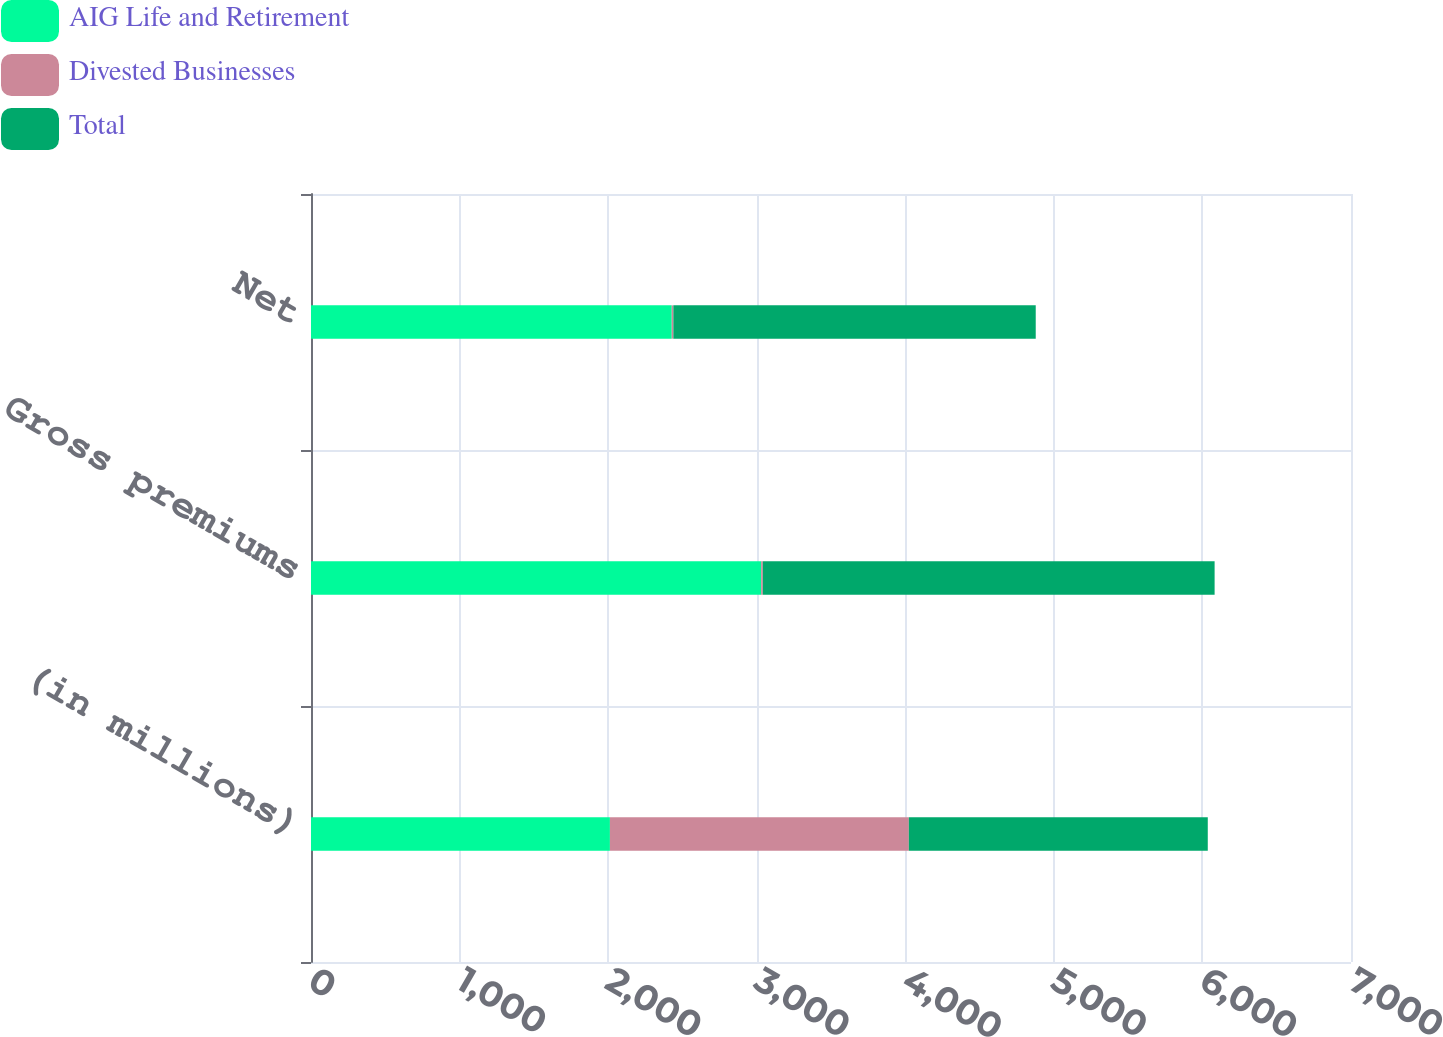Convert chart to OTSL. <chart><loc_0><loc_0><loc_500><loc_500><stacked_bar_chart><ecel><fcel>(in millions)<fcel>Gross premiums<fcel>Net<nl><fcel>AIG Life and Retirement<fcel>2012<fcel>3030<fcel>2428<nl><fcel>Divested Businesses<fcel>2012<fcel>11<fcel>11<nl><fcel>Total<fcel>2012<fcel>3041<fcel>2439<nl></chart> 